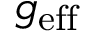Convert formula to latex. <formula><loc_0><loc_0><loc_500><loc_500>g _ { e f f }</formula> 